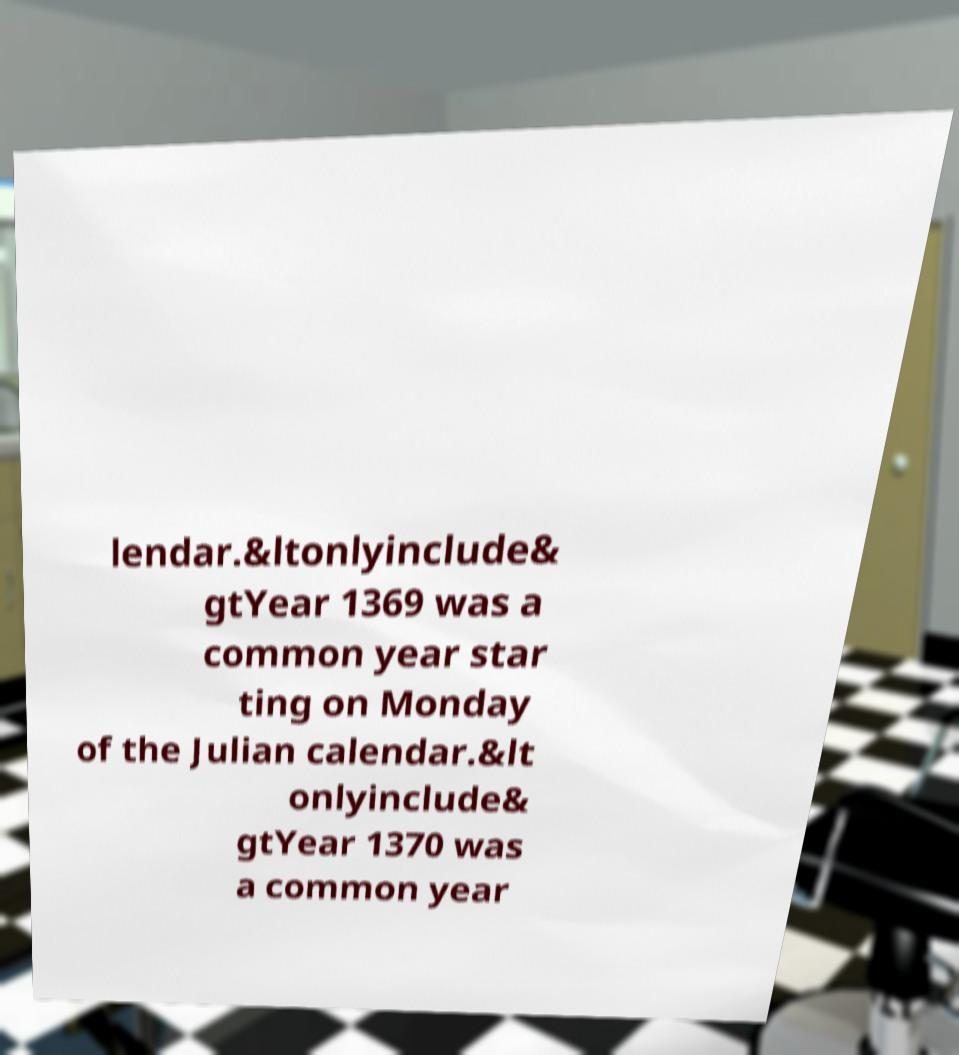Can you accurately transcribe the text from the provided image for me? lendar.&ltonlyinclude& gtYear 1369 was a common year star ting on Monday of the Julian calendar.&lt onlyinclude& gtYear 1370 was a common year 